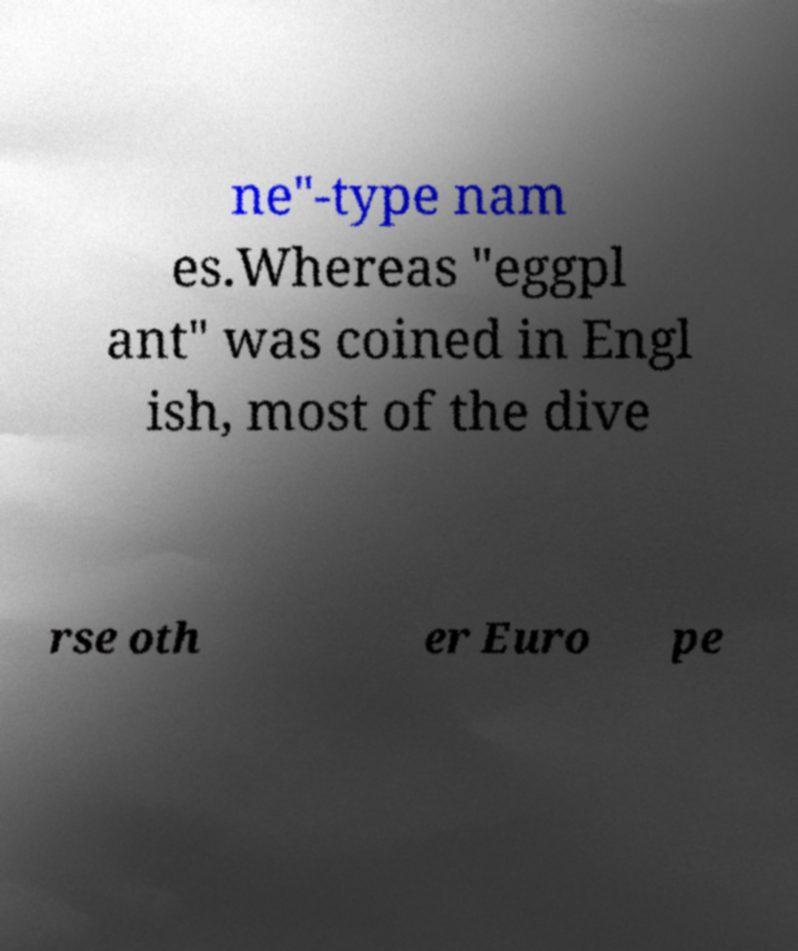Can you read and provide the text displayed in the image?This photo seems to have some interesting text. Can you extract and type it out for me? ne"-type nam es.Whereas "eggpl ant" was coined in Engl ish, most of the dive rse oth er Euro pe 